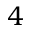Convert formula to latex. <formula><loc_0><loc_0><loc_500><loc_500>4</formula> 